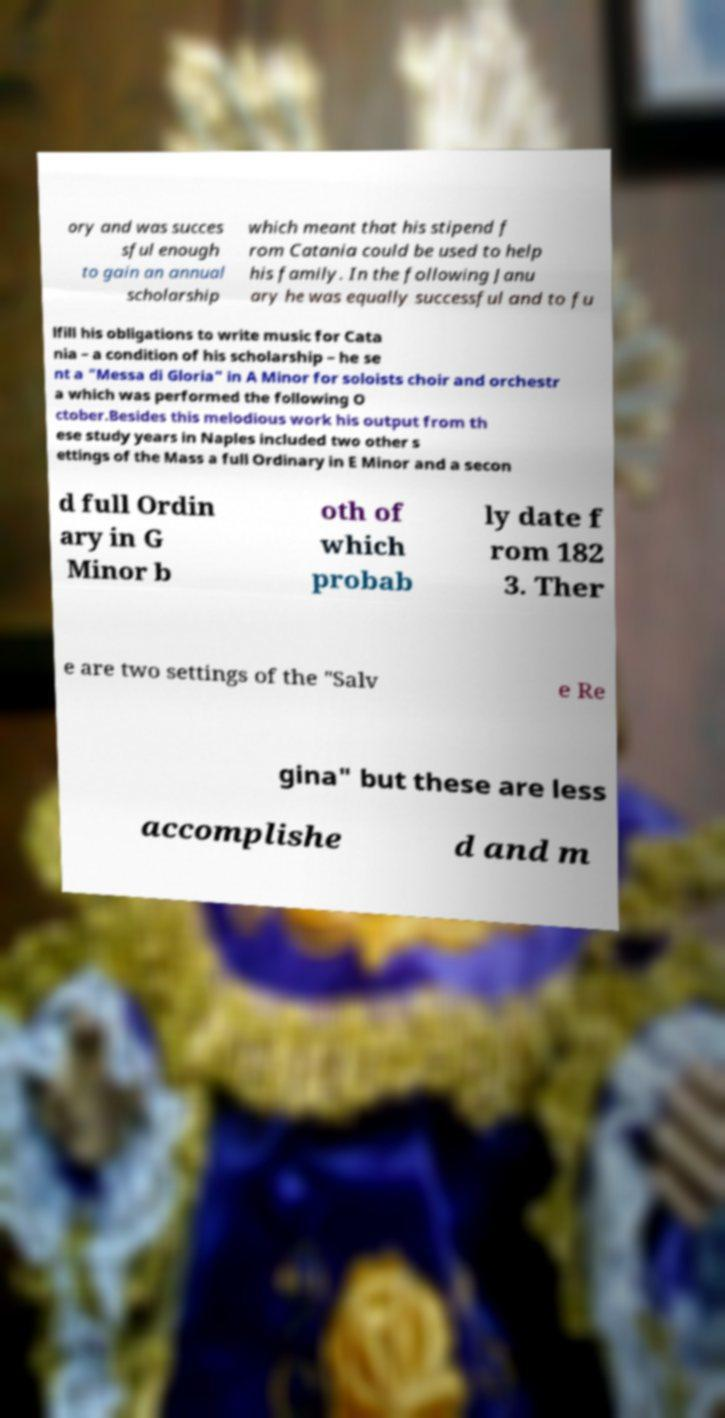Can you accurately transcribe the text from the provided image for me? ory and was succes sful enough to gain an annual scholarship which meant that his stipend f rom Catania could be used to help his family. In the following Janu ary he was equally successful and to fu lfill his obligations to write music for Cata nia – a condition of his scholarship – he se nt a "Messa di Gloria" in A Minor for soloists choir and orchestr a which was performed the following O ctober.Besides this melodious work his output from th ese study years in Naples included two other s ettings of the Mass a full Ordinary in E Minor and a secon d full Ordin ary in G Minor b oth of which probab ly date f rom 182 3. Ther e are two settings of the "Salv e Re gina" but these are less accomplishe d and m 